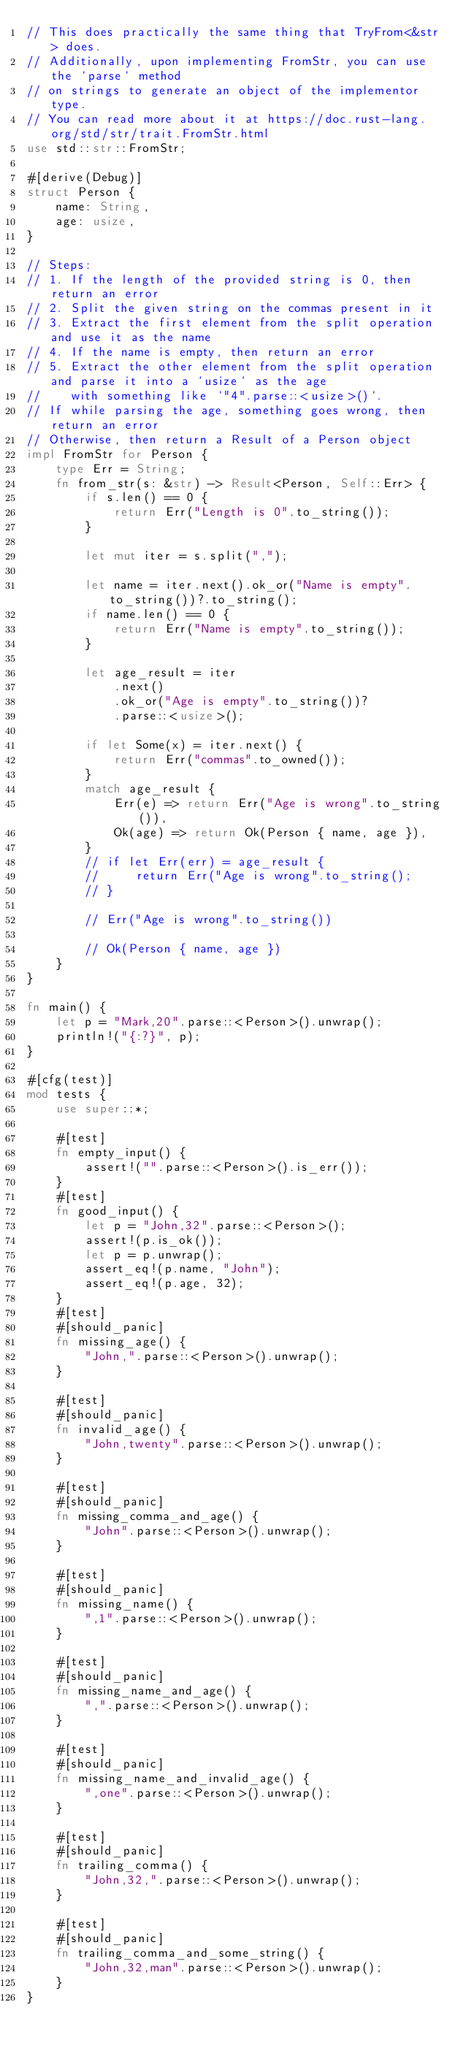Convert code to text. <code><loc_0><loc_0><loc_500><loc_500><_Rust_>// This does practically the same thing that TryFrom<&str> does.
// Additionally, upon implementing FromStr, you can use the `parse` method
// on strings to generate an object of the implementor type.
// You can read more about it at https://doc.rust-lang.org/std/str/trait.FromStr.html
use std::str::FromStr;

#[derive(Debug)]
struct Person {
    name: String,
    age: usize,
}

// Steps:
// 1. If the length of the provided string is 0, then return an error
// 2. Split the given string on the commas present in it
// 3. Extract the first element from the split operation and use it as the name
// 4. If the name is empty, then return an error
// 5. Extract the other element from the split operation and parse it into a `usize` as the age
//    with something like `"4".parse::<usize>()`.
// If while parsing the age, something goes wrong, then return an error
// Otherwise, then return a Result of a Person object
impl FromStr for Person {
    type Err = String;
    fn from_str(s: &str) -> Result<Person, Self::Err> {
        if s.len() == 0 {
            return Err("Length is 0".to_string());
        }

        let mut iter = s.split(",");

        let name = iter.next().ok_or("Name is empty".to_string())?.to_string();
        if name.len() == 0 {
            return Err("Name is empty".to_string());
        }

        let age_result = iter
            .next()
            .ok_or("Age is empty".to_string())?
            .parse::<usize>();

        if let Some(x) = iter.next() {
            return Err("commas".to_owned());
        }
        match age_result {
            Err(e) => return Err("Age is wrong".to_string()),
            Ok(age) => return Ok(Person { name, age }),
        }
        // if let Err(err) = age_result {
        //     return Err("Age is wrong".to_string();
        // }

        // Err("Age is wrong".to_string())

        // Ok(Person { name, age })
    }
}

fn main() {
    let p = "Mark,20".parse::<Person>().unwrap();
    println!("{:?}", p);
}

#[cfg(test)]
mod tests {
    use super::*;

    #[test]
    fn empty_input() {
        assert!("".parse::<Person>().is_err());
    }
    #[test]
    fn good_input() {
        let p = "John,32".parse::<Person>();
        assert!(p.is_ok());
        let p = p.unwrap();
        assert_eq!(p.name, "John");
        assert_eq!(p.age, 32);
    }
    #[test]
    #[should_panic]
    fn missing_age() {
        "John,".parse::<Person>().unwrap();
    }

    #[test]
    #[should_panic]
    fn invalid_age() {
        "John,twenty".parse::<Person>().unwrap();
    }

    #[test]
    #[should_panic]
    fn missing_comma_and_age() {
        "John".parse::<Person>().unwrap();
    }

    #[test]
    #[should_panic]
    fn missing_name() {
        ",1".parse::<Person>().unwrap();
    }

    #[test]
    #[should_panic]
    fn missing_name_and_age() {
        ",".parse::<Person>().unwrap();
    }

    #[test]
    #[should_panic]
    fn missing_name_and_invalid_age() {
        ",one".parse::<Person>().unwrap();
    }

    #[test]
    #[should_panic]
    fn trailing_comma() {
        "John,32,".parse::<Person>().unwrap();
    }

    #[test]
    #[should_panic]
    fn trailing_comma_and_some_string() {
        "John,32,man".parse::<Person>().unwrap();
    }
}
</code> 